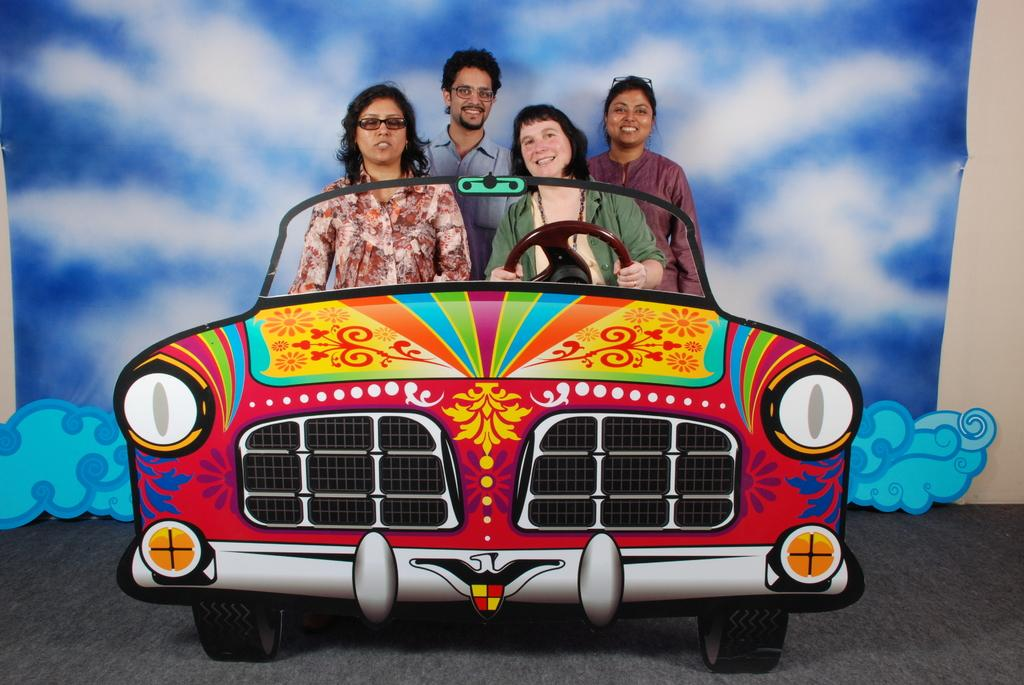How many people are in the image? There are four people in the image. What is the gender distribution of the people in the image? Three of the people are girls, and one is a boy. What vehicle is present in the image? There is a car in the image. What part of the car is visible in the image? The steering part and tires are visible in the image. What type of texture can be seen on the bucket in the image? There is no bucket present in the image. 